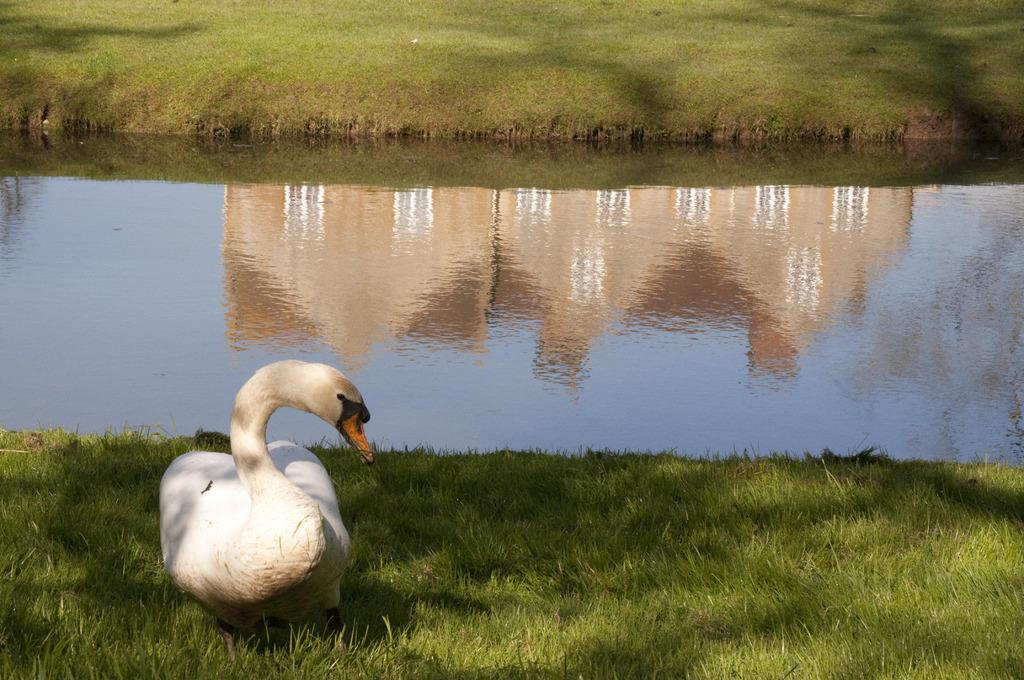Please provide a concise description of this image. In the image we can see there is a swan sitting on the ground and ground is covered with grass. There is water and reflection of building can be seen in the water. Behind there is a ground covered with grass. 